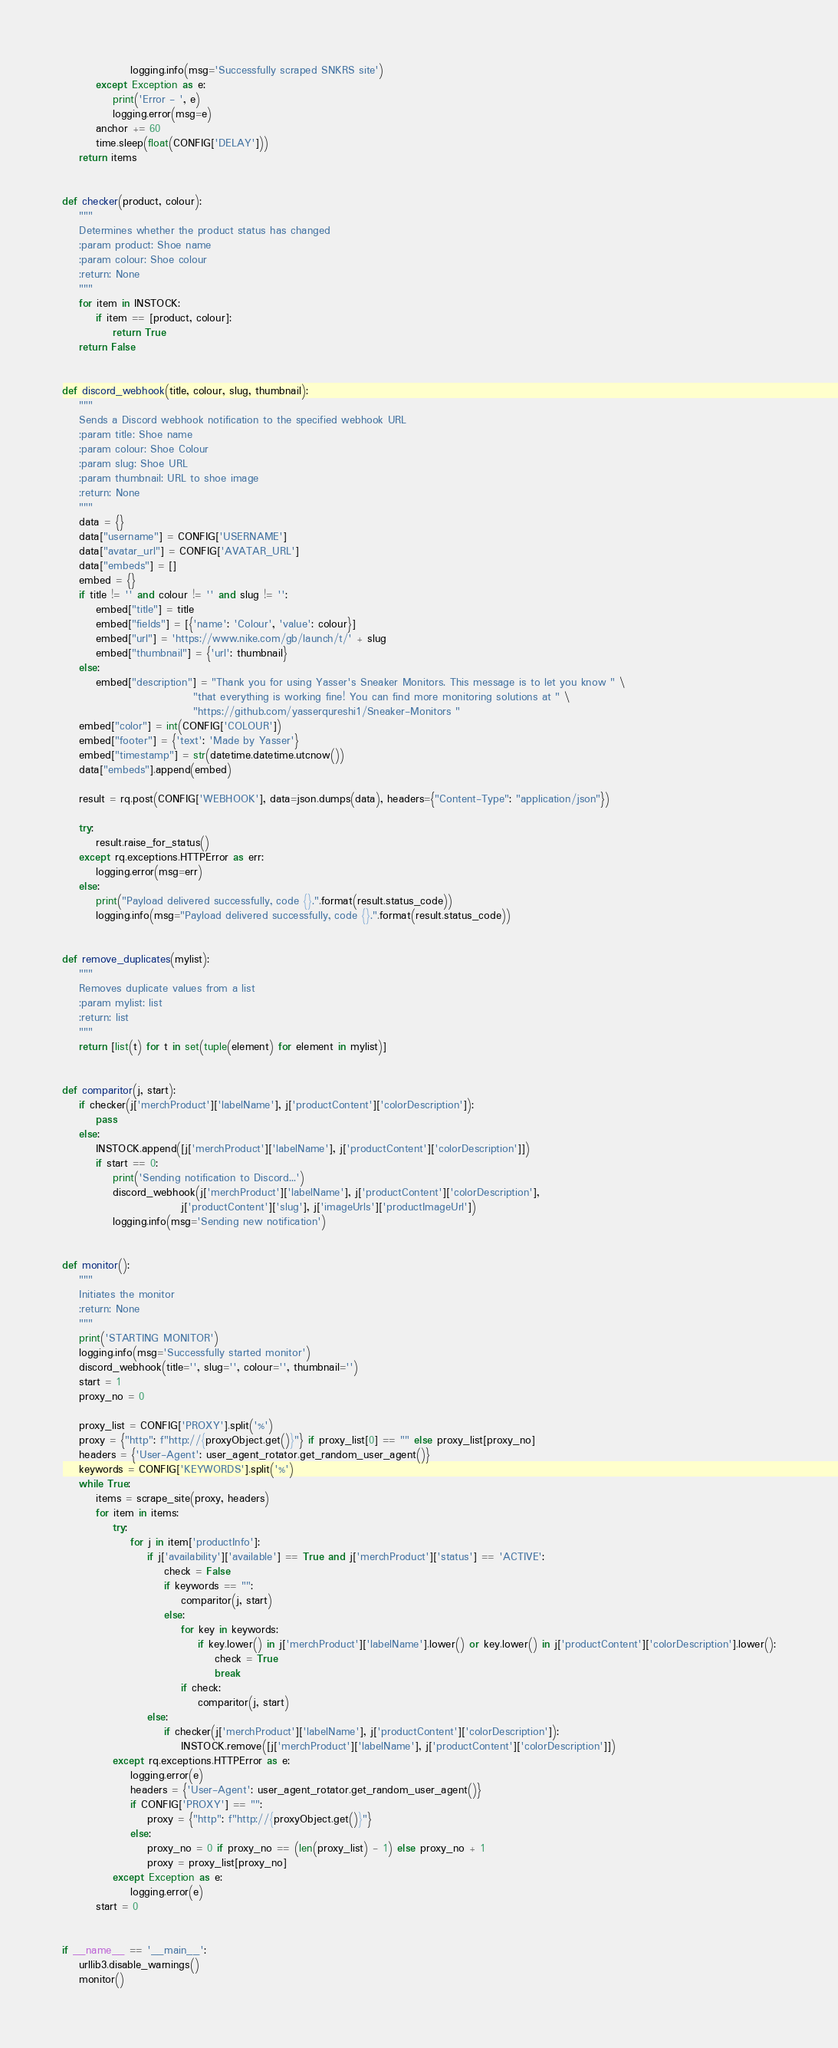Convert code to text. <code><loc_0><loc_0><loc_500><loc_500><_Python_>                logging.info(msg='Successfully scraped SNKRS site')
        except Exception as e:
            print('Error - ', e)
            logging.error(msg=e)
        anchor += 60
        time.sleep(float(CONFIG['DELAY']))
    return items


def checker(product, colour):
    """
    Determines whether the product status has changed
    :param product: Shoe name
    :param colour: Shoe colour
    :return: None
    """
    for item in INSTOCK:
        if item == [product, colour]:
            return True
    return False


def discord_webhook(title, colour, slug, thumbnail):
    """
    Sends a Discord webhook notification to the specified webhook URL
    :param title: Shoe name
    :param colour: Shoe Colour
    :param slug: Shoe URL
    :param thumbnail: URL to shoe image
    :return: None
    """
    data = {}
    data["username"] = CONFIG['USERNAME']
    data["avatar_url"] = CONFIG['AVATAR_URL']
    data["embeds"] = []
    embed = {}
    if title != '' and colour != '' and slug != '':
        embed["title"] = title
        embed["fields"] = [{'name': 'Colour', 'value': colour}]
        embed["url"] = 'https://www.nike.com/gb/launch/t/' + slug
        embed["thumbnail"] = {'url': thumbnail}
    else:
        embed["description"] = "Thank you for using Yasser's Sneaker Monitors. This message is to let you know " \
                               "that everything is working fine! You can find more monitoring solutions at " \
                               "https://github.com/yasserqureshi1/Sneaker-Monitors "
    embed["color"] = int(CONFIG['COLOUR'])
    embed["footer"] = {'text': 'Made by Yasser'}
    embed["timestamp"] = str(datetime.datetime.utcnow())
    data["embeds"].append(embed)

    result = rq.post(CONFIG['WEBHOOK'], data=json.dumps(data), headers={"Content-Type": "application/json"})

    try:
        result.raise_for_status()
    except rq.exceptions.HTTPError as err:
        logging.error(msg=err)
    else:
        print("Payload delivered successfully, code {}.".format(result.status_code))
        logging.info(msg="Payload delivered successfully, code {}.".format(result.status_code))


def remove_duplicates(mylist):
    """
    Removes duplicate values from a list
    :param mylist: list
    :return: list
    """
    return [list(t) for t in set(tuple(element) for element in mylist)]


def comparitor(j, start):
    if checker(j['merchProduct']['labelName'], j['productContent']['colorDescription']):
        pass
    else:
        INSTOCK.append([j['merchProduct']['labelName'], j['productContent']['colorDescription']])
        if start == 0:
            print('Sending notification to Discord...')
            discord_webhook(j['merchProduct']['labelName'], j['productContent']['colorDescription'],
                            j['productContent']['slug'], j['imageUrls']['productImageUrl'])
            logging.info(msg='Sending new notification')


def monitor():
    """
    Initiates the monitor
    :return: None
    """
    print('STARTING MONITOR')
    logging.info(msg='Successfully started monitor')
    discord_webhook(title='', slug='', colour='', thumbnail='')
    start = 1
    proxy_no = 0

    proxy_list = CONFIG['PROXY'].split('%')
    proxy = {"http": f"http://{proxyObject.get()}"} if proxy_list[0] == "" else proxy_list[proxy_no]
    headers = {'User-Agent': user_agent_rotator.get_random_user_agent()}
    keywords = CONFIG['KEYWORDS'].split('%')
    while True:
        items = scrape_site(proxy, headers)
        for item in items:
            try:
                for j in item['productInfo']:
                    if j['availability']['available'] == True and j['merchProduct']['status'] == 'ACTIVE':
                        check = False
                        if keywords == "":
                            comparitor(j, start)
                        else:
                            for key in keywords:
                                if key.lower() in j['merchProduct']['labelName'].lower() or key.lower() in j['productContent']['colorDescription'].lower():
                                    check = True
                                    break
                            if check:
                                comparitor(j, start)
                    else:
                        if checker(j['merchProduct']['labelName'], j['productContent']['colorDescription']):
                            INSTOCK.remove([j['merchProduct']['labelName'], j['productContent']['colorDescription']])
            except rq.exceptions.HTTPError as e:
                logging.error(e)
                headers = {'User-Agent': user_agent_rotator.get_random_user_agent()}
                if CONFIG['PROXY'] == "":
                    proxy = {"http": f"http://{proxyObject.get()}"}
                else:
                    proxy_no = 0 if proxy_no == (len(proxy_list) - 1) else proxy_no + 1
                    proxy = proxy_list[proxy_no]
            except Exception as e:
                logging.error(e)
        start = 0


if __name__ == '__main__':
    urllib3.disable_warnings()
    monitor()
</code> 